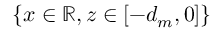<formula> <loc_0><loc_0><loc_500><loc_500>\{ x \in \mathbb { R } , z \in [ - d _ { m } , 0 ] \}</formula> 